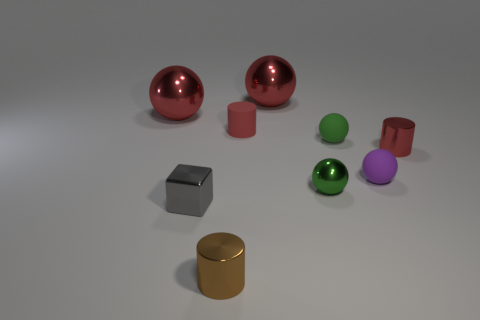What number of other things are the same material as the small brown cylinder?
Provide a short and direct response. 5. What number of large objects are red cylinders or cylinders?
Make the answer very short. 0. Is the material of the tiny gray block the same as the tiny brown cylinder?
Offer a terse response. Yes. There is a tiny shiny cylinder that is to the right of the tiny red matte object; how many red matte things are in front of it?
Your answer should be very brief. 0. Is there a small red thing that has the same shape as the small gray metallic thing?
Give a very brief answer. No. Does the red shiny thing on the left side of the gray thing have the same shape as the small green thing that is in front of the tiny purple thing?
Your answer should be compact. Yes. The small thing that is both behind the purple ball and on the right side of the green rubber thing has what shape?
Ensure brevity in your answer.  Cylinder. Are there any gray cubes that have the same size as the brown metal cylinder?
Your answer should be compact. Yes. Do the tiny block and the cylinder left of the small matte cylinder have the same color?
Keep it short and to the point. No. What is the brown object made of?
Ensure brevity in your answer.  Metal. 